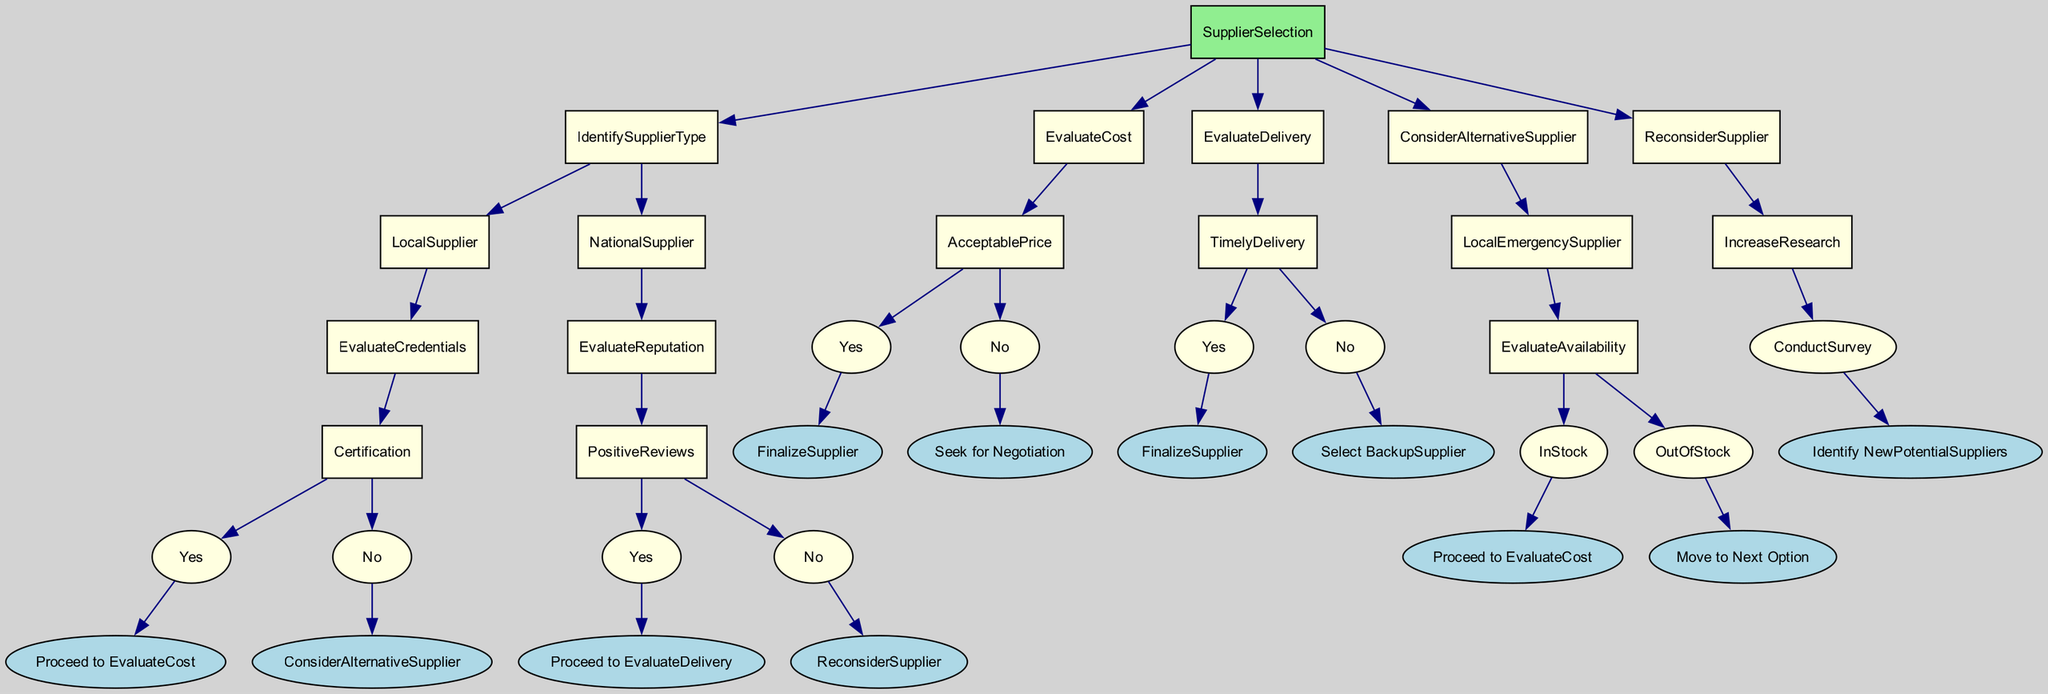What is the first step in the supplier selection process? The first step in the diagram is to "IdentifySupplierType," which indicates that the process begins by determining what kind of supplier (Local or National) will be evaluated.
Answer: IdentifySupplierType How many options are available under Local Supplier? Under Local Supplier, there is one option available, which is "EvaluateCredentials." Therefore, there is only one further decision point for Local Supplier.
Answer: 1 What happens if the National Supplier has negative reviews? If the National Supplier has negative reviews, the process directs to "ReconsiderSupplier," suggesting the need for further assessment and research into the supplier’s reputation.
Answer: ReconsiderSupplier If a Local Supplier is not certified, which option is pursued next? If a Local Supplier is not certified, the decision directs to "ConsiderAlternativeSupplier," indicating a need to look for different suppliers who may be able to fulfill the needs.
Answer: ConsiderAlternativeSupplier What must be evaluated after a Local Emergency Supplier is found to be in stock? After confirming that a Local Emergency Supplier is in stock, the process directs us to "EvaluateCost," meaning the next step is to assess the cost associated with that supplier.
Answer: EvaluateCost What happens if the delivery from a National Supplier is not timely? If the delivery from a National Supplier is not timely, the tree directs to "Select BackupSupplier," indicating that an alternative supplier should be considered for reliability in delivery.
Answer: Select BackupSupplier What follows if the cost of supplies is not acceptable? If the cost of supplies is not acceptable, the next step is to "Seek for Negotiation," meaning that the business will attempt to negotiate a better price with the current supplier.
Answer: Seek for Negotiation What should be done if a supplier needs to be researched further? If a supplier needs more research due to negative reviews, the diagram indicates to "IncreaseResearch," leading to conducting surveys to identify new potential suppliers.
Answer: IncreaseResearch 